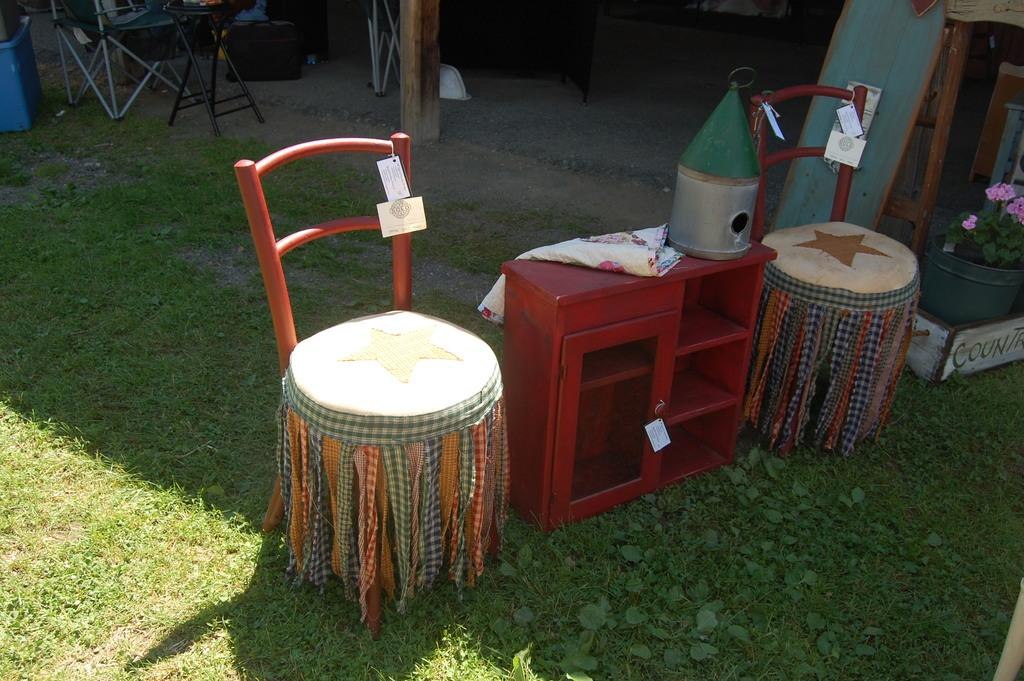What type of furniture is present in the image? There are stools and chairs visible in the image. What is located in the middle of the image? There is a wooden box in the middle of the image. What type of vegetation can be seen on the right side of the image? There are flowers and plants on the right side of the image. What type of veil is draped over the wooden box in the image? There is no veil present in the image; it only features stools, chairs, a wooden box, and flowers and plants. What decisions is the committee making in the image? There is no committee present in the image, so no decisions are being made. 